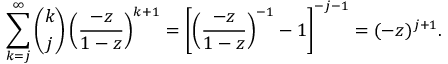Convert formula to latex. <formula><loc_0><loc_0><loc_500><loc_500>\sum _ { k = j } ^ { \infty } { \binom { k } { j } } \left ( { \frac { - z } { 1 - z } } \right ) ^ { k + 1 } = \left [ \left ( { \frac { - z } { 1 - z } } \right ) ^ { - 1 } - 1 \right ] ^ { - j - 1 } = ( - z ) ^ { j + 1 } .</formula> 